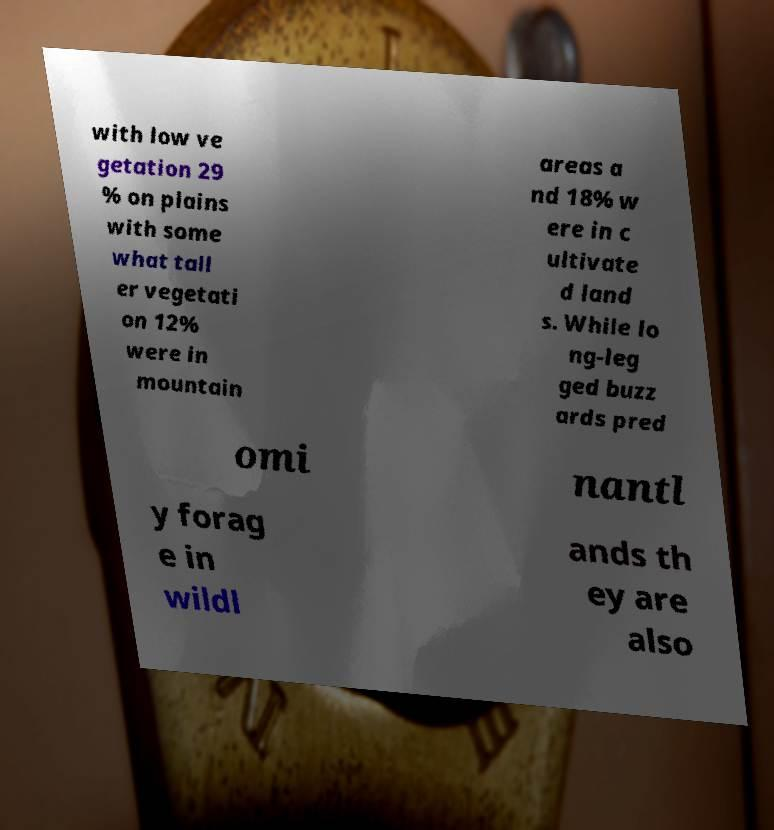Could you assist in decoding the text presented in this image and type it out clearly? with low ve getation 29 % on plains with some what tall er vegetati on 12% were in mountain areas a nd 18% w ere in c ultivate d land s. While lo ng-leg ged buzz ards pred omi nantl y forag e in wildl ands th ey are also 